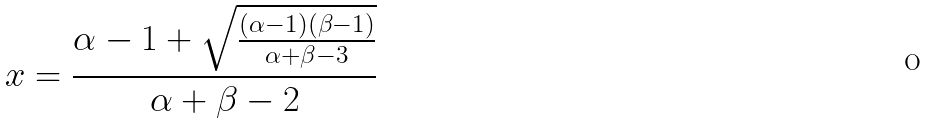<formula> <loc_0><loc_0><loc_500><loc_500>x = { \frac { \alpha - 1 + { \sqrt { \frac { ( \alpha - 1 ) ( \beta - 1 ) } { \alpha + \beta - 3 } } } } { \alpha + \beta - 2 } }</formula> 